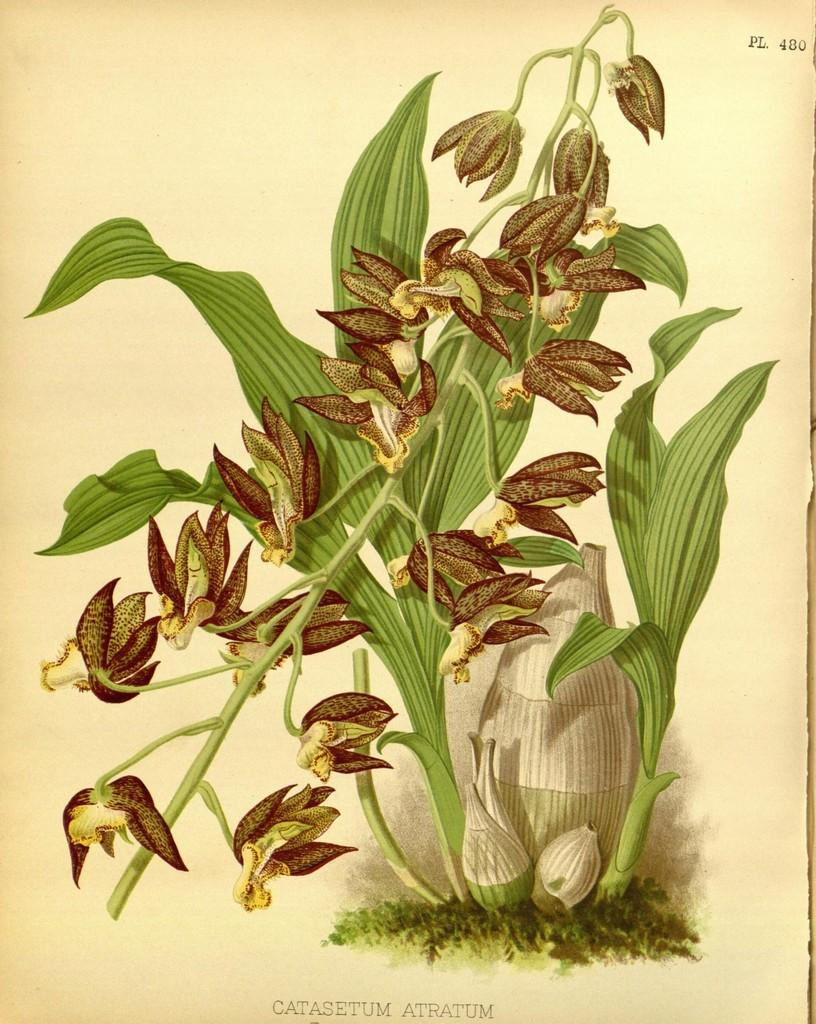What is the medium of the image? The image might be a painting on paper. What is depicted in the image? There is a plant in the image. What additional detail can be observed about the plant? The plant has flowers. How does the plant change its color during recess in the image? The image does not depict a scene with a plant changing its color during recess, as it is a static representation of the plant with flowers. 